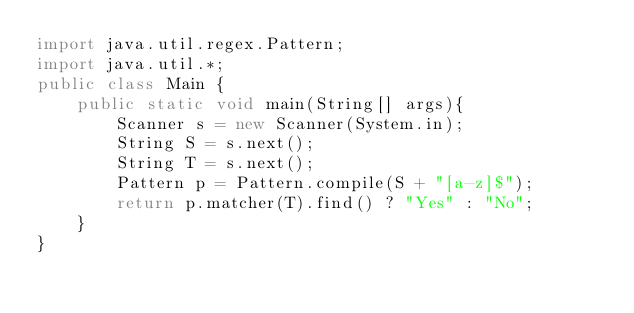Convert code to text. <code><loc_0><loc_0><loc_500><loc_500><_Java_>import java.util.regex.Pattern;
import java.util.*;
public class Main {
    public static void main(String[] args){
        Scanner s = new Scanner(System.in);
        String S = s.next();
      	String T = s.next();
		Pattern p = Pattern.compile(S + "[a-z]$");
		return p.matcher(T).find() ? "Yes" : "No";
    }
}</code> 